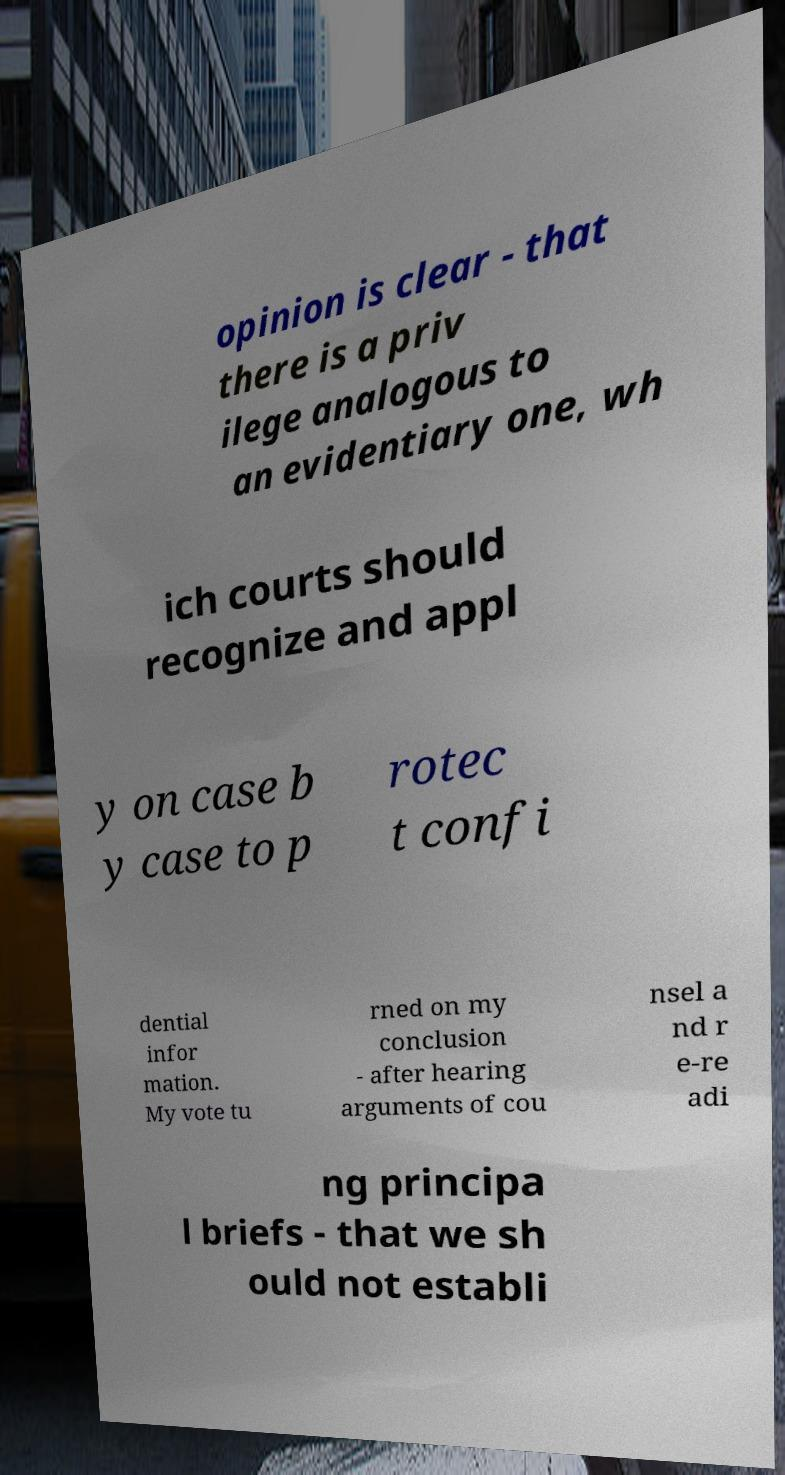Could you extract and type out the text from this image? opinion is clear - that there is a priv ilege analogous to an evidentiary one, wh ich courts should recognize and appl y on case b y case to p rotec t confi dential infor mation. My vote tu rned on my conclusion - after hearing arguments of cou nsel a nd r e-re adi ng principa l briefs - that we sh ould not establi 